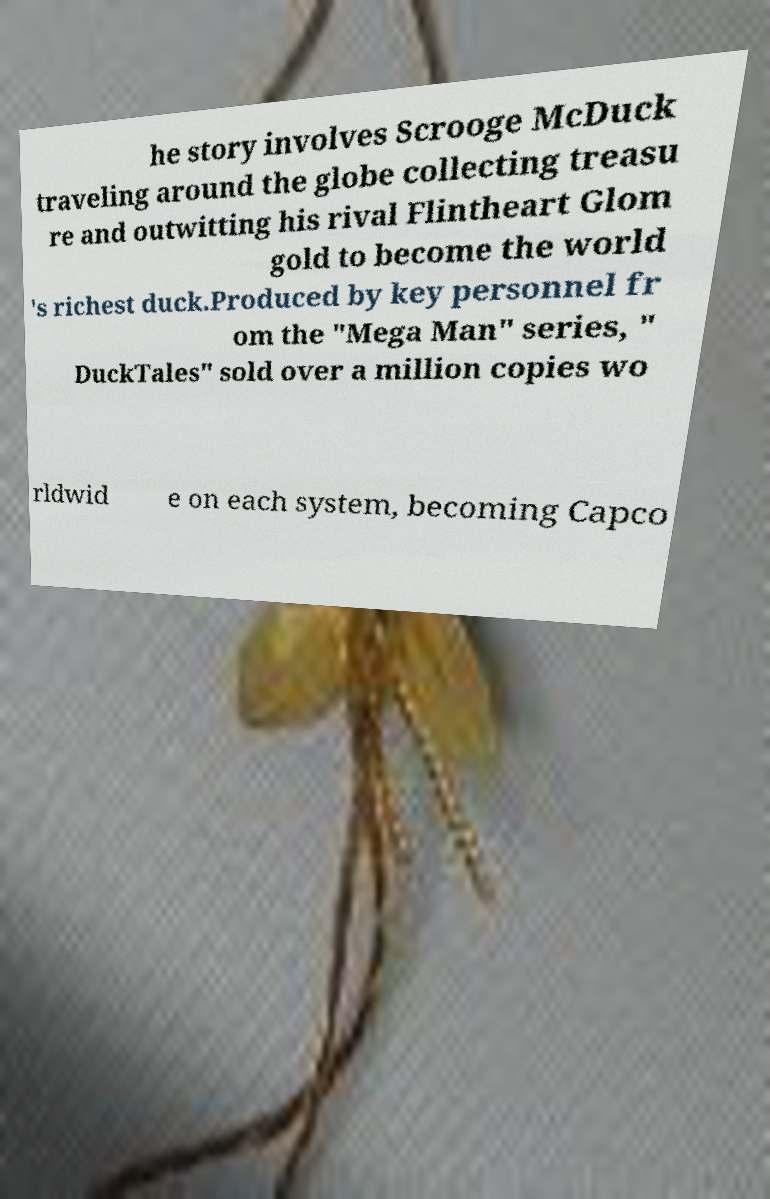For documentation purposes, I need the text within this image transcribed. Could you provide that? he story involves Scrooge McDuck traveling around the globe collecting treasu re and outwitting his rival Flintheart Glom gold to become the world 's richest duck.Produced by key personnel fr om the "Mega Man" series, " DuckTales" sold over a million copies wo rldwid e on each system, becoming Capco 